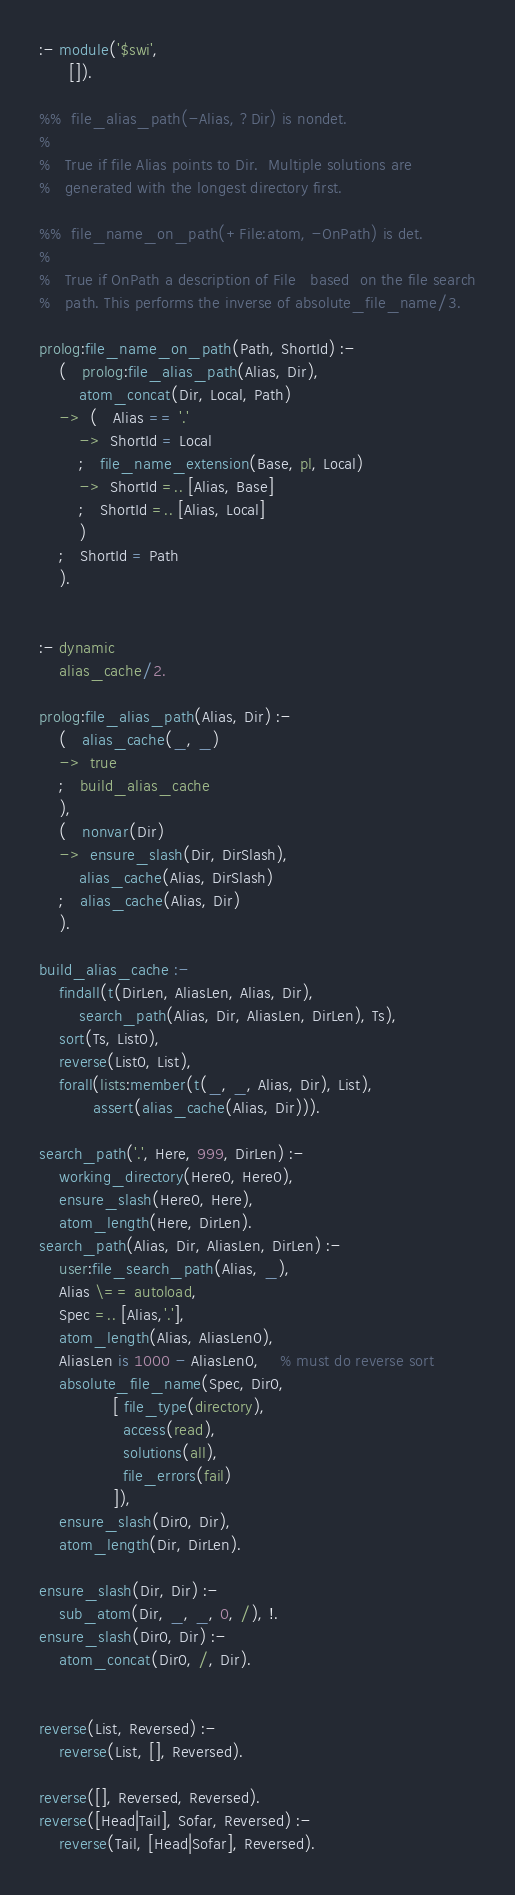Convert code to text. <code><loc_0><loc_0><loc_500><loc_500><_Prolog_>:- module('$swi',
	  []).

%%	file_alias_path(-Alias, ?Dir) is nondet.
%
%	True if file Alias points to Dir.  Multiple solutions are
%	generated with the longest directory first.

%%	file_name_on_path(+File:atom, -OnPath) is det.
%
%	True if OnPath a description of File   based  on the file search
%	path. This performs the inverse of absolute_file_name/3.

prolog:file_name_on_path(Path, ShortId) :-
	(   prolog:file_alias_path(Alias, Dir),
	    atom_concat(Dir, Local, Path)
	->  (   Alias == '.'
	    ->  ShortId = Local
	    ;   file_name_extension(Base, pl, Local)
	    ->  ShortId =.. [Alias, Base]
	    ;   ShortId =.. [Alias, Local]
	    )
	;   ShortId = Path
	).


:- dynamic
	alias_cache/2.

prolog:file_alias_path(Alias, Dir) :-
	(   alias_cache(_, _)
	->  true
	;   build_alias_cache
	),
	(   nonvar(Dir)
	->  ensure_slash(Dir, DirSlash),
	    alias_cache(Alias, DirSlash)
	;   alias_cache(Alias, Dir)
	).

build_alias_cache :-
	findall(t(DirLen, AliasLen, Alias, Dir),
		search_path(Alias, Dir, AliasLen, DirLen), Ts),
	sort(Ts, List0),
	reverse(List0, List),
	forall(lists:member(t(_, _, Alias, Dir), List),
	       assert(alias_cache(Alias, Dir))).

search_path('.', Here, 999, DirLen) :-
	working_directory(Here0, Here0),
	ensure_slash(Here0, Here),
	atom_length(Here, DirLen).
search_path(Alias, Dir, AliasLen, DirLen) :-
	user:file_search_path(Alias, _),
	Alias \== autoload,
	Spec =.. [Alias,'.'],
	atom_length(Alias, AliasLen0),
	AliasLen is 1000 - AliasLen0,	% must do reverse sort
	absolute_file_name(Spec, Dir0,
			   [ file_type(directory),
			     access(read),
			     solutions(all),
			     file_errors(fail)
			   ]),
	ensure_slash(Dir0, Dir),
	atom_length(Dir, DirLen).

ensure_slash(Dir, Dir) :-
	sub_atom(Dir, _, _, 0, /), !.
ensure_slash(Dir0, Dir) :-
	atom_concat(Dir0, /, Dir).


reverse(List, Reversed) :-
	reverse(List, [], Reversed).

reverse([], Reversed, Reversed).
reverse([Head|Tail], Sofar, Reversed) :-
	reverse(Tail, [Head|Sofar], Reversed).


</code> 